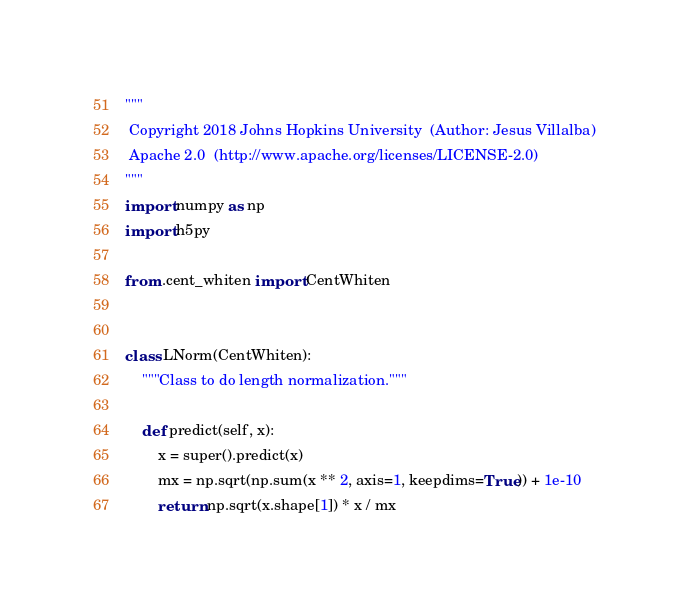<code> <loc_0><loc_0><loc_500><loc_500><_Python_>"""
 Copyright 2018 Johns Hopkins University  (Author: Jesus Villalba)
 Apache 2.0  (http://www.apache.org/licenses/LICENSE-2.0)
"""
import numpy as np
import h5py

from .cent_whiten import CentWhiten


class LNorm(CentWhiten):
    """Class to do length normalization."""

    def predict(self, x):
        x = super().predict(x)
        mx = np.sqrt(np.sum(x ** 2, axis=1, keepdims=True)) + 1e-10
        return np.sqrt(x.shape[1]) * x / mx
</code> 